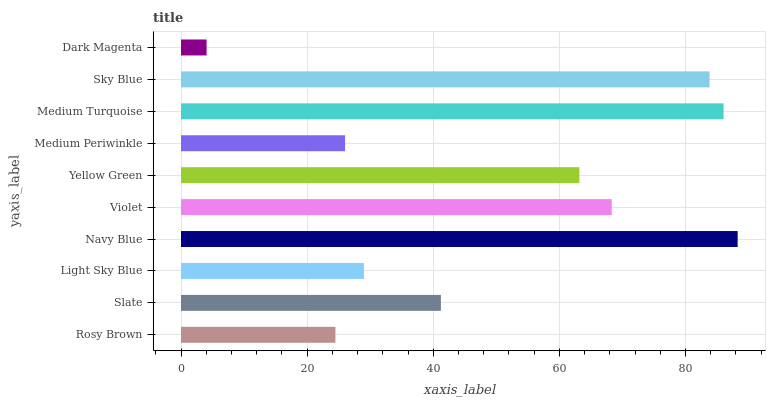Is Dark Magenta the minimum?
Answer yes or no. Yes. Is Navy Blue the maximum?
Answer yes or no. Yes. Is Slate the minimum?
Answer yes or no. No. Is Slate the maximum?
Answer yes or no. No. Is Slate greater than Rosy Brown?
Answer yes or no. Yes. Is Rosy Brown less than Slate?
Answer yes or no. Yes. Is Rosy Brown greater than Slate?
Answer yes or no. No. Is Slate less than Rosy Brown?
Answer yes or no. No. Is Yellow Green the high median?
Answer yes or no. Yes. Is Slate the low median?
Answer yes or no. Yes. Is Violet the high median?
Answer yes or no. No. Is Navy Blue the low median?
Answer yes or no. No. 